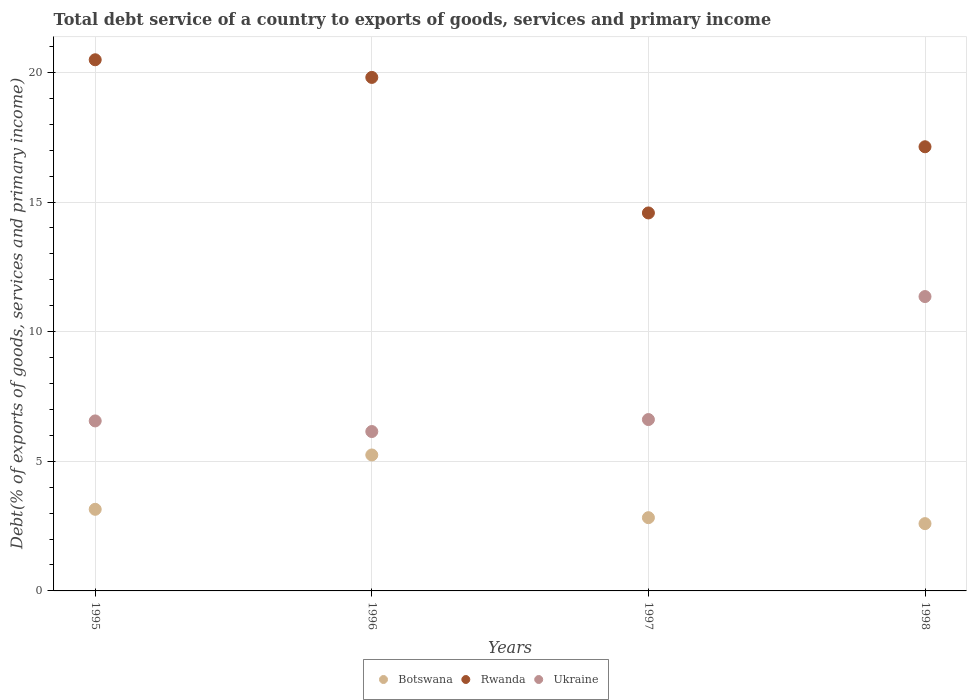How many different coloured dotlines are there?
Keep it short and to the point. 3. What is the total debt service in Rwanda in 1995?
Keep it short and to the point. 20.49. Across all years, what is the maximum total debt service in Botswana?
Ensure brevity in your answer.  5.24. Across all years, what is the minimum total debt service in Rwanda?
Your response must be concise. 14.58. In which year was the total debt service in Rwanda maximum?
Keep it short and to the point. 1995. In which year was the total debt service in Ukraine minimum?
Make the answer very short. 1996. What is the total total debt service in Botswana in the graph?
Make the answer very short. 13.81. What is the difference between the total debt service in Rwanda in 1995 and that in 1996?
Keep it short and to the point. 0.68. What is the difference between the total debt service in Ukraine in 1998 and the total debt service in Rwanda in 1997?
Your answer should be very brief. -3.23. What is the average total debt service in Botswana per year?
Your answer should be compact. 3.45. In the year 1996, what is the difference between the total debt service in Botswana and total debt service in Rwanda?
Your response must be concise. -14.56. In how many years, is the total debt service in Botswana greater than 14 %?
Provide a short and direct response. 0. What is the ratio of the total debt service in Rwanda in 1995 to that in 1996?
Offer a terse response. 1.03. Is the difference between the total debt service in Botswana in 1997 and 1998 greater than the difference between the total debt service in Rwanda in 1997 and 1998?
Offer a terse response. Yes. What is the difference between the highest and the second highest total debt service in Rwanda?
Provide a succinct answer. 0.68. What is the difference between the highest and the lowest total debt service in Botswana?
Provide a short and direct response. 2.65. In how many years, is the total debt service in Rwanda greater than the average total debt service in Rwanda taken over all years?
Provide a short and direct response. 2. Is the sum of the total debt service in Rwanda in 1995 and 1996 greater than the maximum total debt service in Ukraine across all years?
Keep it short and to the point. Yes. Is it the case that in every year, the sum of the total debt service in Ukraine and total debt service in Botswana  is greater than the total debt service in Rwanda?
Ensure brevity in your answer.  No. Does the total debt service in Rwanda monotonically increase over the years?
Your answer should be compact. No. How many dotlines are there?
Offer a terse response. 3. How many years are there in the graph?
Your answer should be very brief. 4. Does the graph contain any zero values?
Your response must be concise. No. What is the title of the graph?
Give a very brief answer. Total debt service of a country to exports of goods, services and primary income. Does "Norway" appear as one of the legend labels in the graph?
Your answer should be very brief. No. What is the label or title of the X-axis?
Your answer should be compact. Years. What is the label or title of the Y-axis?
Provide a succinct answer. Debt(% of exports of goods, services and primary income). What is the Debt(% of exports of goods, services and primary income) of Botswana in 1995?
Give a very brief answer. 3.15. What is the Debt(% of exports of goods, services and primary income) of Rwanda in 1995?
Provide a short and direct response. 20.49. What is the Debt(% of exports of goods, services and primary income) of Ukraine in 1995?
Your answer should be very brief. 6.56. What is the Debt(% of exports of goods, services and primary income) in Botswana in 1996?
Ensure brevity in your answer.  5.24. What is the Debt(% of exports of goods, services and primary income) of Rwanda in 1996?
Provide a short and direct response. 19.81. What is the Debt(% of exports of goods, services and primary income) of Ukraine in 1996?
Offer a very short reply. 6.15. What is the Debt(% of exports of goods, services and primary income) in Botswana in 1997?
Offer a terse response. 2.83. What is the Debt(% of exports of goods, services and primary income) in Rwanda in 1997?
Offer a terse response. 14.58. What is the Debt(% of exports of goods, services and primary income) in Ukraine in 1997?
Your answer should be very brief. 6.61. What is the Debt(% of exports of goods, services and primary income) of Botswana in 1998?
Your answer should be compact. 2.6. What is the Debt(% of exports of goods, services and primary income) in Rwanda in 1998?
Your answer should be compact. 17.13. What is the Debt(% of exports of goods, services and primary income) of Ukraine in 1998?
Give a very brief answer. 11.35. Across all years, what is the maximum Debt(% of exports of goods, services and primary income) in Botswana?
Provide a succinct answer. 5.24. Across all years, what is the maximum Debt(% of exports of goods, services and primary income) in Rwanda?
Offer a very short reply. 20.49. Across all years, what is the maximum Debt(% of exports of goods, services and primary income) of Ukraine?
Your answer should be very brief. 11.35. Across all years, what is the minimum Debt(% of exports of goods, services and primary income) in Botswana?
Ensure brevity in your answer.  2.6. Across all years, what is the minimum Debt(% of exports of goods, services and primary income) in Rwanda?
Provide a short and direct response. 14.58. Across all years, what is the minimum Debt(% of exports of goods, services and primary income) of Ukraine?
Offer a very short reply. 6.15. What is the total Debt(% of exports of goods, services and primary income) of Botswana in the graph?
Your response must be concise. 13.81. What is the total Debt(% of exports of goods, services and primary income) in Rwanda in the graph?
Make the answer very short. 72. What is the total Debt(% of exports of goods, services and primary income) in Ukraine in the graph?
Offer a terse response. 30.67. What is the difference between the Debt(% of exports of goods, services and primary income) in Botswana in 1995 and that in 1996?
Your response must be concise. -2.1. What is the difference between the Debt(% of exports of goods, services and primary income) in Rwanda in 1995 and that in 1996?
Offer a very short reply. 0.68. What is the difference between the Debt(% of exports of goods, services and primary income) in Ukraine in 1995 and that in 1996?
Ensure brevity in your answer.  0.41. What is the difference between the Debt(% of exports of goods, services and primary income) in Botswana in 1995 and that in 1997?
Offer a very short reply. 0.32. What is the difference between the Debt(% of exports of goods, services and primary income) of Rwanda in 1995 and that in 1997?
Your answer should be very brief. 5.91. What is the difference between the Debt(% of exports of goods, services and primary income) in Ukraine in 1995 and that in 1997?
Your answer should be compact. -0.05. What is the difference between the Debt(% of exports of goods, services and primary income) of Botswana in 1995 and that in 1998?
Your answer should be compact. 0.55. What is the difference between the Debt(% of exports of goods, services and primary income) in Rwanda in 1995 and that in 1998?
Offer a terse response. 3.36. What is the difference between the Debt(% of exports of goods, services and primary income) in Ukraine in 1995 and that in 1998?
Your response must be concise. -4.8. What is the difference between the Debt(% of exports of goods, services and primary income) in Botswana in 1996 and that in 1997?
Your answer should be compact. 2.42. What is the difference between the Debt(% of exports of goods, services and primary income) of Rwanda in 1996 and that in 1997?
Offer a very short reply. 5.23. What is the difference between the Debt(% of exports of goods, services and primary income) in Ukraine in 1996 and that in 1997?
Make the answer very short. -0.46. What is the difference between the Debt(% of exports of goods, services and primary income) in Botswana in 1996 and that in 1998?
Provide a short and direct response. 2.65. What is the difference between the Debt(% of exports of goods, services and primary income) of Rwanda in 1996 and that in 1998?
Provide a short and direct response. 2.67. What is the difference between the Debt(% of exports of goods, services and primary income) of Ukraine in 1996 and that in 1998?
Ensure brevity in your answer.  -5.21. What is the difference between the Debt(% of exports of goods, services and primary income) in Botswana in 1997 and that in 1998?
Offer a very short reply. 0.23. What is the difference between the Debt(% of exports of goods, services and primary income) in Rwanda in 1997 and that in 1998?
Offer a terse response. -2.55. What is the difference between the Debt(% of exports of goods, services and primary income) of Ukraine in 1997 and that in 1998?
Ensure brevity in your answer.  -4.74. What is the difference between the Debt(% of exports of goods, services and primary income) of Botswana in 1995 and the Debt(% of exports of goods, services and primary income) of Rwanda in 1996?
Give a very brief answer. -16.66. What is the difference between the Debt(% of exports of goods, services and primary income) of Botswana in 1995 and the Debt(% of exports of goods, services and primary income) of Ukraine in 1996?
Offer a very short reply. -3. What is the difference between the Debt(% of exports of goods, services and primary income) in Rwanda in 1995 and the Debt(% of exports of goods, services and primary income) in Ukraine in 1996?
Ensure brevity in your answer.  14.34. What is the difference between the Debt(% of exports of goods, services and primary income) of Botswana in 1995 and the Debt(% of exports of goods, services and primary income) of Rwanda in 1997?
Offer a very short reply. -11.43. What is the difference between the Debt(% of exports of goods, services and primary income) in Botswana in 1995 and the Debt(% of exports of goods, services and primary income) in Ukraine in 1997?
Your answer should be very brief. -3.46. What is the difference between the Debt(% of exports of goods, services and primary income) in Rwanda in 1995 and the Debt(% of exports of goods, services and primary income) in Ukraine in 1997?
Provide a succinct answer. 13.88. What is the difference between the Debt(% of exports of goods, services and primary income) of Botswana in 1995 and the Debt(% of exports of goods, services and primary income) of Rwanda in 1998?
Your answer should be compact. -13.98. What is the difference between the Debt(% of exports of goods, services and primary income) of Botswana in 1995 and the Debt(% of exports of goods, services and primary income) of Ukraine in 1998?
Offer a terse response. -8.21. What is the difference between the Debt(% of exports of goods, services and primary income) of Rwanda in 1995 and the Debt(% of exports of goods, services and primary income) of Ukraine in 1998?
Your answer should be compact. 9.13. What is the difference between the Debt(% of exports of goods, services and primary income) of Botswana in 1996 and the Debt(% of exports of goods, services and primary income) of Rwanda in 1997?
Provide a short and direct response. -9.33. What is the difference between the Debt(% of exports of goods, services and primary income) in Botswana in 1996 and the Debt(% of exports of goods, services and primary income) in Ukraine in 1997?
Provide a succinct answer. -1.37. What is the difference between the Debt(% of exports of goods, services and primary income) of Rwanda in 1996 and the Debt(% of exports of goods, services and primary income) of Ukraine in 1997?
Keep it short and to the point. 13.2. What is the difference between the Debt(% of exports of goods, services and primary income) of Botswana in 1996 and the Debt(% of exports of goods, services and primary income) of Rwanda in 1998?
Your answer should be compact. -11.89. What is the difference between the Debt(% of exports of goods, services and primary income) in Botswana in 1996 and the Debt(% of exports of goods, services and primary income) in Ukraine in 1998?
Your response must be concise. -6.11. What is the difference between the Debt(% of exports of goods, services and primary income) of Rwanda in 1996 and the Debt(% of exports of goods, services and primary income) of Ukraine in 1998?
Offer a terse response. 8.45. What is the difference between the Debt(% of exports of goods, services and primary income) of Botswana in 1997 and the Debt(% of exports of goods, services and primary income) of Rwanda in 1998?
Keep it short and to the point. -14.31. What is the difference between the Debt(% of exports of goods, services and primary income) in Botswana in 1997 and the Debt(% of exports of goods, services and primary income) in Ukraine in 1998?
Provide a short and direct response. -8.53. What is the difference between the Debt(% of exports of goods, services and primary income) in Rwanda in 1997 and the Debt(% of exports of goods, services and primary income) in Ukraine in 1998?
Give a very brief answer. 3.23. What is the average Debt(% of exports of goods, services and primary income) in Botswana per year?
Keep it short and to the point. 3.45. What is the average Debt(% of exports of goods, services and primary income) in Rwanda per year?
Provide a short and direct response. 18. What is the average Debt(% of exports of goods, services and primary income) of Ukraine per year?
Your response must be concise. 7.67. In the year 1995, what is the difference between the Debt(% of exports of goods, services and primary income) in Botswana and Debt(% of exports of goods, services and primary income) in Rwanda?
Make the answer very short. -17.34. In the year 1995, what is the difference between the Debt(% of exports of goods, services and primary income) of Botswana and Debt(% of exports of goods, services and primary income) of Ukraine?
Keep it short and to the point. -3.41. In the year 1995, what is the difference between the Debt(% of exports of goods, services and primary income) of Rwanda and Debt(% of exports of goods, services and primary income) of Ukraine?
Provide a succinct answer. 13.93. In the year 1996, what is the difference between the Debt(% of exports of goods, services and primary income) in Botswana and Debt(% of exports of goods, services and primary income) in Rwanda?
Give a very brief answer. -14.56. In the year 1996, what is the difference between the Debt(% of exports of goods, services and primary income) in Botswana and Debt(% of exports of goods, services and primary income) in Ukraine?
Your response must be concise. -0.9. In the year 1996, what is the difference between the Debt(% of exports of goods, services and primary income) of Rwanda and Debt(% of exports of goods, services and primary income) of Ukraine?
Provide a short and direct response. 13.66. In the year 1997, what is the difference between the Debt(% of exports of goods, services and primary income) in Botswana and Debt(% of exports of goods, services and primary income) in Rwanda?
Keep it short and to the point. -11.75. In the year 1997, what is the difference between the Debt(% of exports of goods, services and primary income) of Botswana and Debt(% of exports of goods, services and primary income) of Ukraine?
Keep it short and to the point. -3.78. In the year 1997, what is the difference between the Debt(% of exports of goods, services and primary income) of Rwanda and Debt(% of exports of goods, services and primary income) of Ukraine?
Your answer should be very brief. 7.97. In the year 1998, what is the difference between the Debt(% of exports of goods, services and primary income) of Botswana and Debt(% of exports of goods, services and primary income) of Rwanda?
Your response must be concise. -14.54. In the year 1998, what is the difference between the Debt(% of exports of goods, services and primary income) in Botswana and Debt(% of exports of goods, services and primary income) in Ukraine?
Ensure brevity in your answer.  -8.76. In the year 1998, what is the difference between the Debt(% of exports of goods, services and primary income) of Rwanda and Debt(% of exports of goods, services and primary income) of Ukraine?
Offer a terse response. 5.78. What is the ratio of the Debt(% of exports of goods, services and primary income) of Botswana in 1995 to that in 1996?
Your answer should be compact. 0.6. What is the ratio of the Debt(% of exports of goods, services and primary income) in Rwanda in 1995 to that in 1996?
Make the answer very short. 1.03. What is the ratio of the Debt(% of exports of goods, services and primary income) of Ukraine in 1995 to that in 1996?
Make the answer very short. 1.07. What is the ratio of the Debt(% of exports of goods, services and primary income) of Botswana in 1995 to that in 1997?
Provide a succinct answer. 1.11. What is the ratio of the Debt(% of exports of goods, services and primary income) of Rwanda in 1995 to that in 1997?
Provide a short and direct response. 1.41. What is the ratio of the Debt(% of exports of goods, services and primary income) in Ukraine in 1995 to that in 1997?
Make the answer very short. 0.99. What is the ratio of the Debt(% of exports of goods, services and primary income) of Botswana in 1995 to that in 1998?
Offer a terse response. 1.21. What is the ratio of the Debt(% of exports of goods, services and primary income) of Rwanda in 1995 to that in 1998?
Provide a succinct answer. 1.2. What is the ratio of the Debt(% of exports of goods, services and primary income) in Ukraine in 1995 to that in 1998?
Keep it short and to the point. 0.58. What is the ratio of the Debt(% of exports of goods, services and primary income) of Botswana in 1996 to that in 1997?
Ensure brevity in your answer.  1.86. What is the ratio of the Debt(% of exports of goods, services and primary income) of Rwanda in 1996 to that in 1997?
Offer a very short reply. 1.36. What is the ratio of the Debt(% of exports of goods, services and primary income) in Ukraine in 1996 to that in 1997?
Keep it short and to the point. 0.93. What is the ratio of the Debt(% of exports of goods, services and primary income) in Botswana in 1996 to that in 1998?
Make the answer very short. 2.02. What is the ratio of the Debt(% of exports of goods, services and primary income) in Rwanda in 1996 to that in 1998?
Keep it short and to the point. 1.16. What is the ratio of the Debt(% of exports of goods, services and primary income) of Ukraine in 1996 to that in 1998?
Your answer should be very brief. 0.54. What is the ratio of the Debt(% of exports of goods, services and primary income) in Botswana in 1997 to that in 1998?
Ensure brevity in your answer.  1.09. What is the ratio of the Debt(% of exports of goods, services and primary income) in Rwanda in 1997 to that in 1998?
Your answer should be very brief. 0.85. What is the ratio of the Debt(% of exports of goods, services and primary income) in Ukraine in 1997 to that in 1998?
Offer a terse response. 0.58. What is the difference between the highest and the second highest Debt(% of exports of goods, services and primary income) in Botswana?
Your answer should be very brief. 2.1. What is the difference between the highest and the second highest Debt(% of exports of goods, services and primary income) of Rwanda?
Offer a terse response. 0.68. What is the difference between the highest and the second highest Debt(% of exports of goods, services and primary income) in Ukraine?
Give a very brief answer. 4.74. What is the difference between the highest and the lowest Debt(% of exports of goods, services and primary income) of Botswana?
Make the answer very short. 2.65. What is the difference between the highest and the lowest Debt(% of exports of goods, services and primary income) in Rwanda?
Ensure brevity in your answer.  5.91. What is the difference between the highest and the lowest Debt(% of exports of goods, services and primary income) of Ukraine?
Your answer should be very brief. 5.21. 